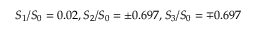Convert formula to latex. <formula><loc_0><loc_0><loc_500><loc_500>S _ { 1 } / S _ { 0 } = 0 . 0 2 , S _ { 2 } / S _ { 0 } = \pm 0 . 6 9 7 , S _ { 3 } / S _ { 0 } = \mp 0 . 6 9 7</formula> 